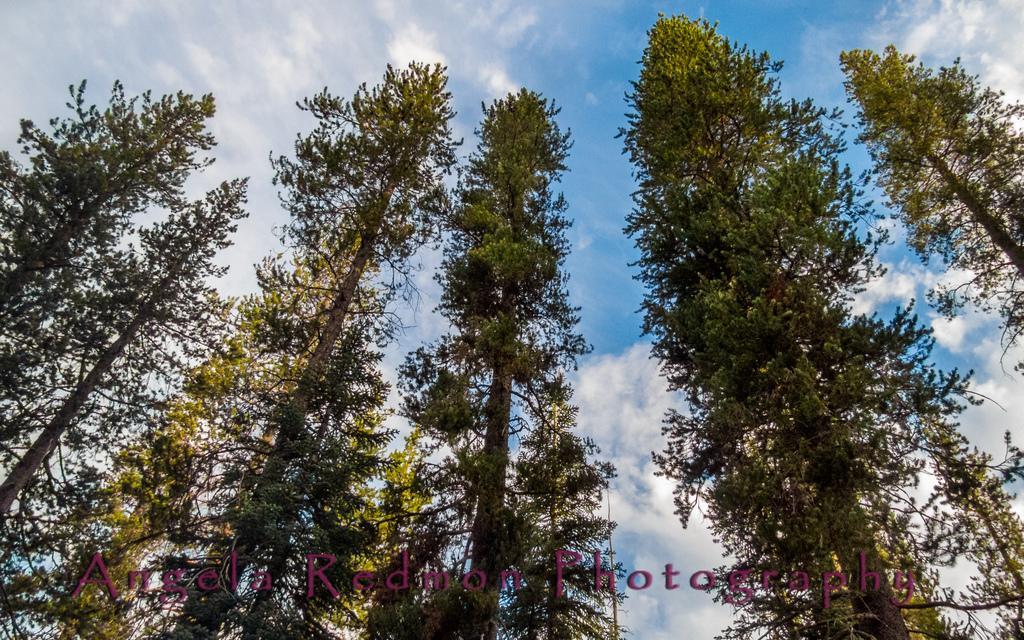Please provide a concise description of this image. In this image we can see trees. At the top of the image there is sky and clouds. There is some text printed at the bottom of the image. 